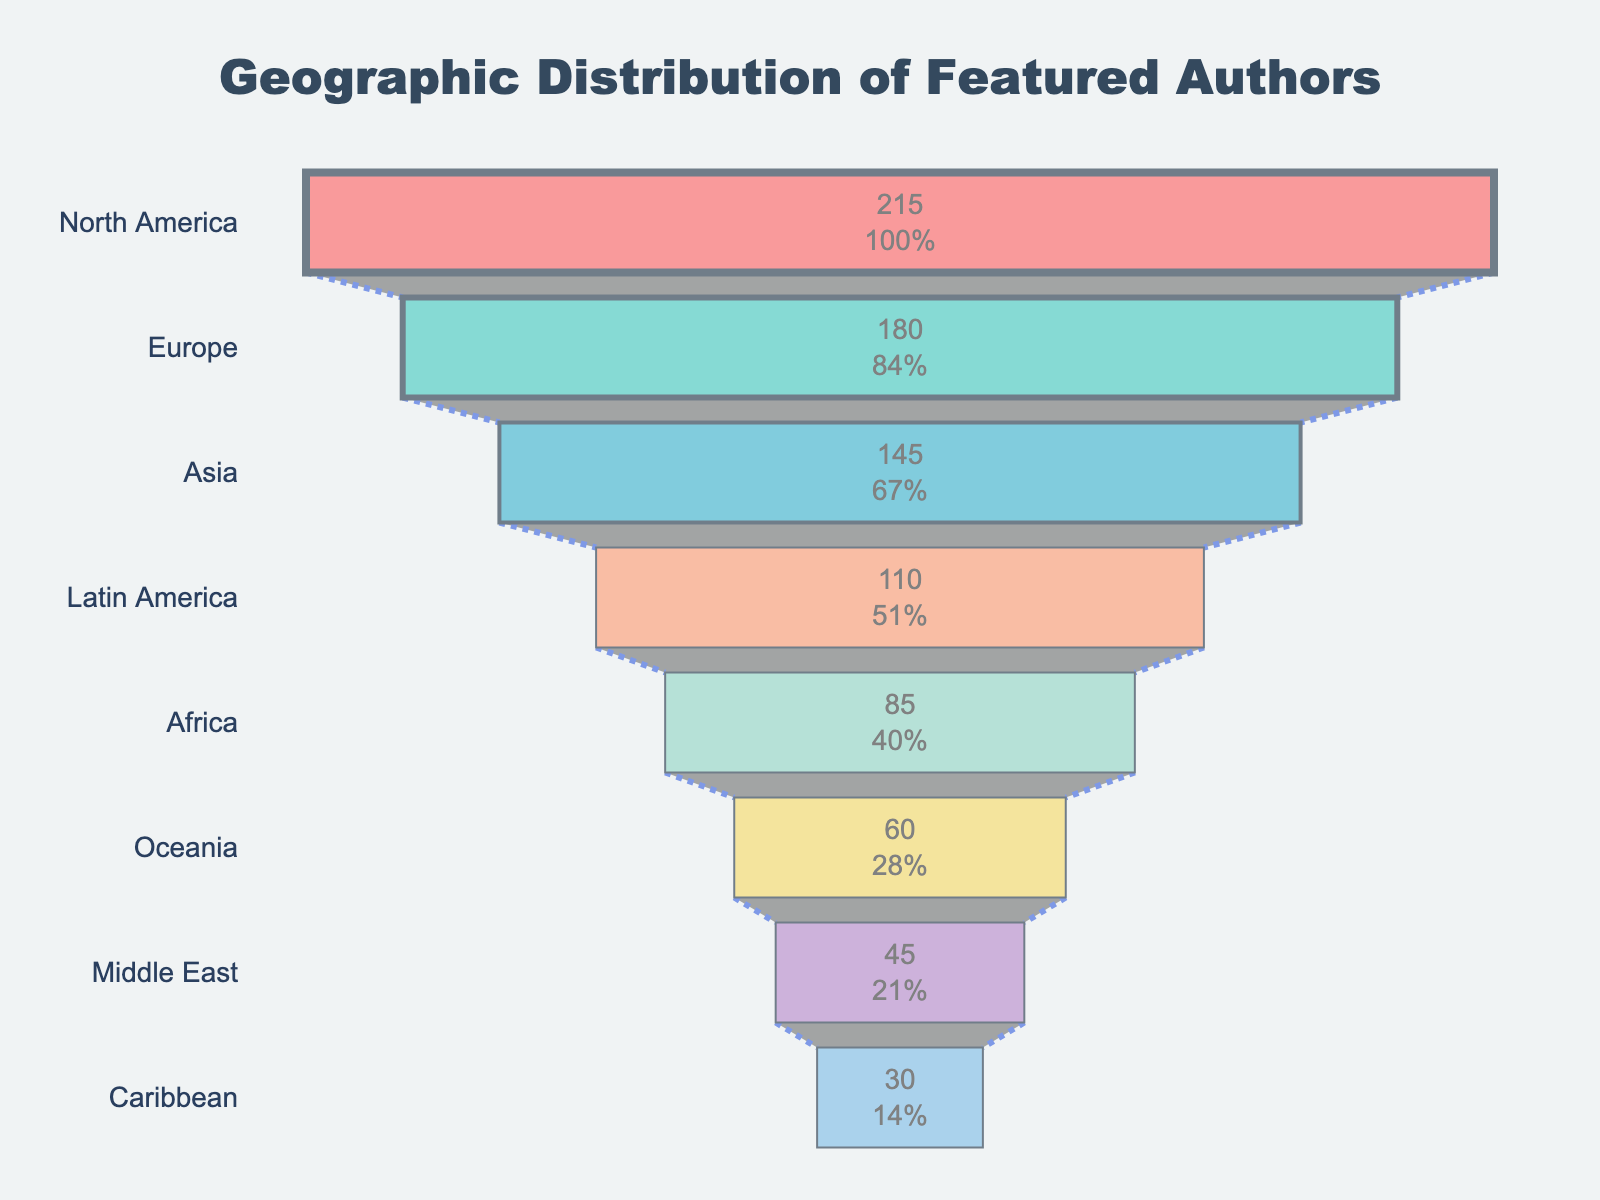What is the title of the chart? The title is usually located at the top of the chart and is meant to provide a concise description of the visual representation. In this case, it should state the focus of the funnel chart.
Answer: Geographic Distribution of Featured Authors Which region has the highest number of authors? To find the region with the highest number of authors, look at the top segment of the funnel chart. The label and value here indicate the most represented region.
Answer: North America How many authors are featured from Oceania? Scan the funnel chart to locate the segment labeled "Oceania." The number within this segment represents the number of authors from that region.
Answer: 60 What is the combined number of authors from Europe and Asia? Identify the number of authors from both Europe and Asia by locating their respective segments in the chart. Then, add these two numbers together. Europe has 180 authors, and Asia has 145 authors. So, the combined total is 180 + 145 = 325.
Answer: 325 Which regions have fewer than 50 authors? Look for the regions that have segments with values less than 50. According to the chart, the regions with fewer than 50 authors are "Middle East" and "Caribbean".
Answer: Middle East and Caribbean What is the percentage of authors from Africa relative to the total number of authors? First, find the number of authors from Africa, which is 85. Then, sum the total number of authors from all regions (215 + 180 + 145 + 110 + 85 + 60 + 45 + 30 = 870). Finally, calculate the percentage: (85/870) * 100 ≈ 9.77%.
Answer: 9.77% Compare the number of authors in Latin America and the Caribbean. Which region has more, and by how many? Find the segments for Latin America (110 authors) and the Caribbean (30 authors). Subtract the number of Caribbean authors from the number of Latin American authors: 110 - 30 = 80. Latin America has more authors by 80.
Answer: Latin America by 80 What is the total number of authors from regions outside North America and Europe? Exclude North America and Europe from the total count of authors. Sum the number of authors from Asia (145), Latin America (110), Africa (85), Oceania (60), Middle East (45), and Caribbean (30). The total is 145 + 110 + 85 + 60 + 45 + 30 = 475.
Answer: 475 What is the average number of authors per region featured in the chart? To find the average, sum the number of authors from all regions and divide by the number of regions. The total number of authors is 870, with 8 regions. So, the average is 870 / 8 = 108.75.
Answer: 108.75 